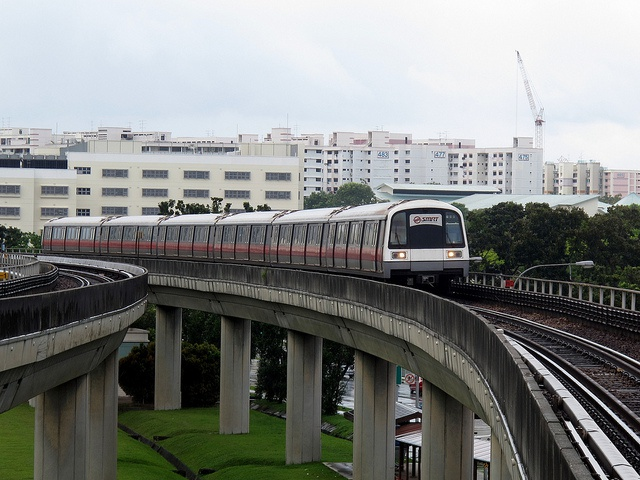Describe the objects in this image and their specific colors. I can see train in white, gray, black, lightgray, and darkgray tones and car in white, black, maroon, gray, and darkgray tones in this image. 